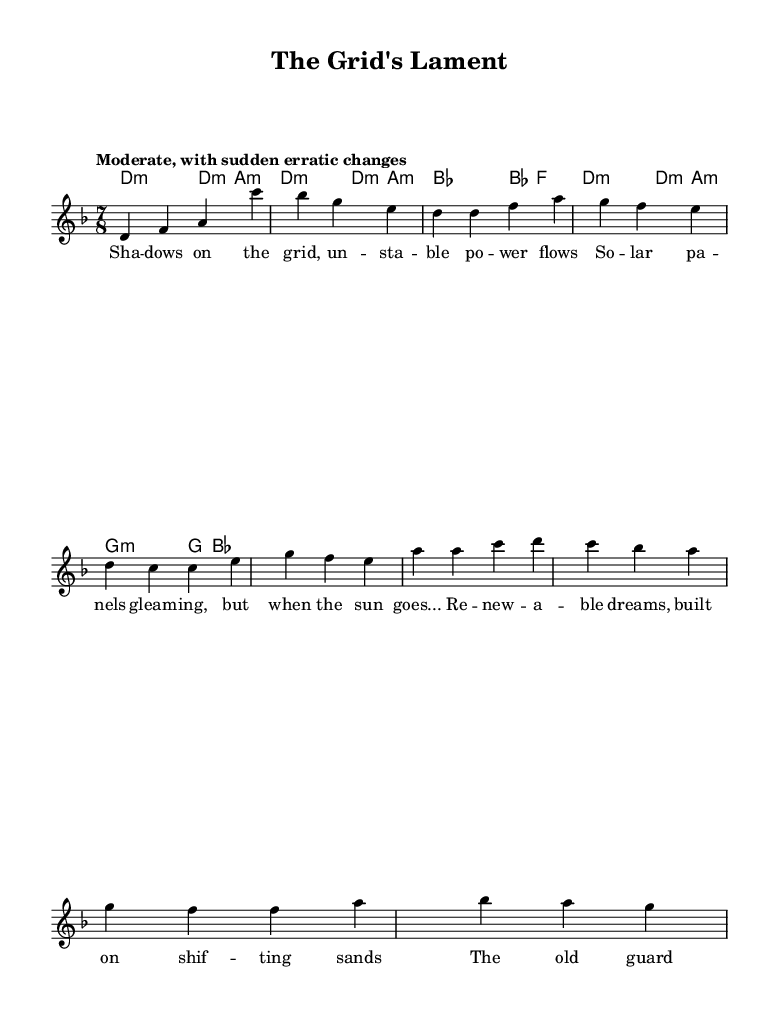What is the key signature of this music? The key signature is D minor, which typically has one flat (B flat). It can be identified in the global music section where the key is set with the command.
Answer: D minor What is the time signature used in this piece? The time signature is indicated in the global section as 7/8. This means there are seven beats in each measure, and the eighth note gets one beat.
Answer: 7/8 What is the tempo marking for this score? The tempo marking is "Moderate, with sudden erratic changes," which suggests an irregular, changing pace throughout the piece.
Answer: Moderate, with sudden erratic changes How many measures are in the verse section? The verse consists of three measures, which can be counted from the melody section specifically where the verse lyrics are applied.
Answer: 3 What predominant musical feature defines this opera as experimental? The use of erratic tempo changes and irregular time signatures, such as the 7/8 time, both contribute to its classification as experimental. These features create an unpredictable and innovative listening experience.
Answer: Erratic tempo changes What are the first two words of the chorus lyrics? The first two words of the chorus can be found in the chorus lyrics section, which states "Renewable dreams." This is the start of the chorus.
Answer: Renewable dreams What instrument is the score primarily composed for in this opera? The score is primarily composed for a voice as indicated by the "Voice = 'lead'" label, with the melody being sung or performed vocally.
Answer: Voice 